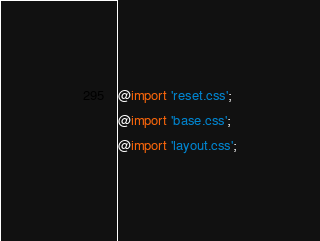Convert code to text. <code><loc_0><loc_0><loc_500><loc_500><_CSS_>@import 'reset.css';
@import 'base.css';
@import 'layout.css';
</code> 